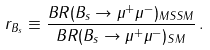<formula> <loc_0><loc_0><loc_500><loc_500>r _ { B _ { s } } \equiv \frac { B R ( B _ { s } \to \mu ^ { + } \mu ^ { - } ) _ { M S S M } } { B R ( B _ { s } \to \mu ^ { + } \mu ^ { - } ) _ { S M } } \, .</formula> 